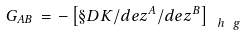<formula> <loc_0><loc_0><loc_500><loc_500>G _ { A B } \, = \, - \left [ \S D K / d e z ^ { A } / d e { z ^ { B } } \right ] _ { \, \ h \ g }</formula> 